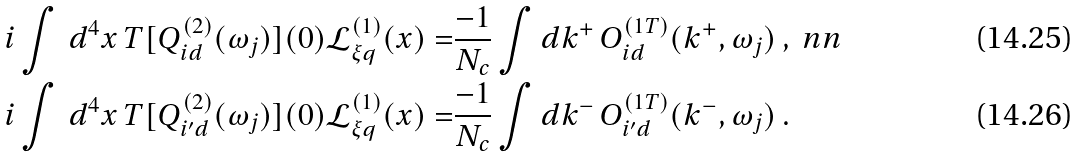<formula> <loc_0><loc_0><loc_500><loc_500>i \int \, d ^ { 4 } x \, T [ Q _ { i d } ^ { ( 2 ) } ( \omega _ { j } ) ] ( 0 ) \mathcal { L } _ { \xi q } ^ { ( 1 ) } ( x ) = & \frac { - 1 } { N _ { c } } \int d k ^ { + } \, O _ { i d } ^ { ( 1 T ) } ( k ^ { + } , \omega _ { j } ) \, , \ n n \\ i \int \, d ^ { 4 } x \, T [ Q _ { i ^ { \prime } d } ^ { ( 2 ) } ( \omega _ { j } ) ] ( 0 ) \mathcal { L } _ { \xi q } ^ { ( 1 ) } ( x ) = & \frac { - 1 } { N _ { c } } \int d k ^ { - } \, O _ { i ^ { \prime } d } ^ { ( 1 T ) } ( k ^ { - } , \omega _ { j } ) \, .</formula> 